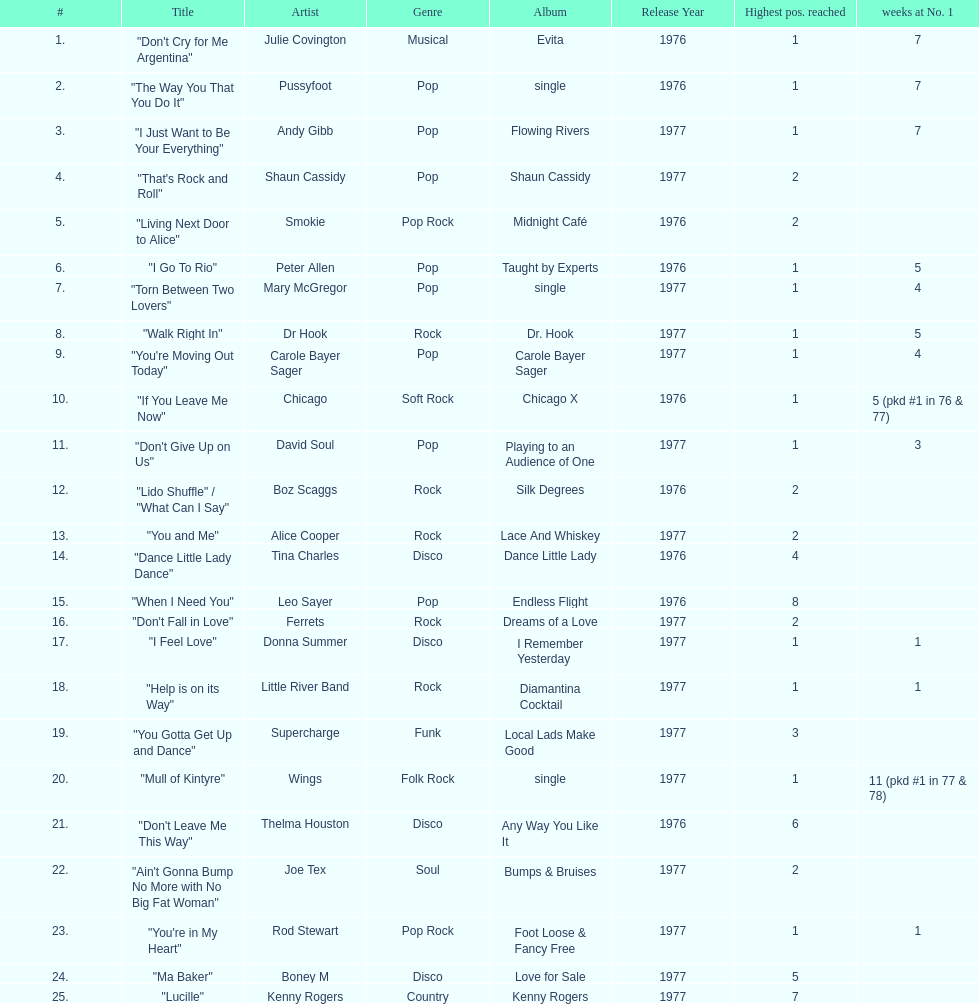How many weeks did julie covington's "don't cry for me argentina" spend at the top of australia's singles chart? 7. 